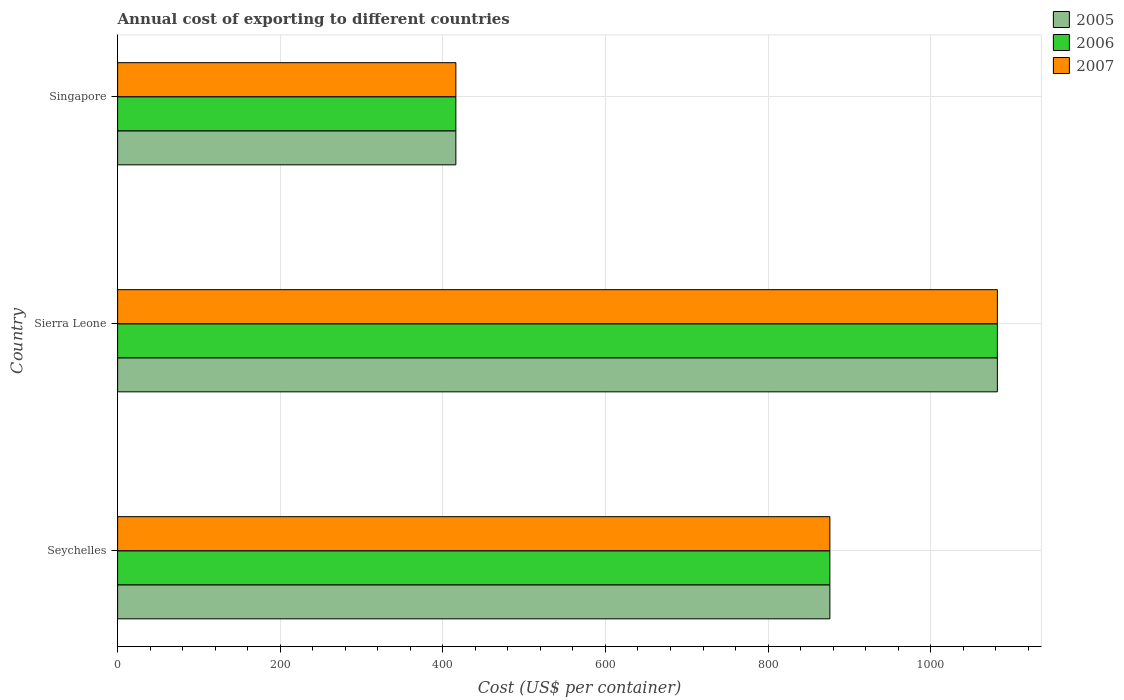Are the number of bars per tick equal to the number of legend labels?
Your answer should be compact. Yes. Are the number of bars on each tick of the Y-axis equal?
Offer a terse response. Yes. What is the label of the 1st group of bars from the top?
Provide a short and direct response. Singapore. In how many cases, is the number of bars for a given country not equal to the number of legend labels?
Provide a short and direct response. 0. What is the total annual cost of exporting in 2007 in Singapore?
Offer a terse response. 416. Across all countries, what is the maximum total annual cost of exporting in 2007?
Give a very brief answer. 1082. Across all countries, what is the minimum total annual cost of exporting in 2007?
Your response must be concise. 416. In which country was the total annual cost of exporting in 2007 maximum?
Offer a very short reply. Sierra Leone. In which country was the total annual cost of exporting in 2007 minimum?
Make the answer very short. Singapore. What is the total total annual cost of exporting in 2006 in the graph?
Offer a very short reply. 2374. What is the difference between the total annual cost of exporting in 2006 in Seychelles and that in Singapore?
Offer a terse response. 460. What is the difference between the total annual cost of exporting in 2005 in Sierra Leone and the total annual cost of exporting in 2006 in Seychelles?
Your answer should be very brief. 206. What is the average total annual cost of exporting in 2006 per country?
Your response must be concise. 791.33. What is the ratio of the total annual cost of exporting in 2007 in Seychelles to that in Sierra Leone?
Offer a terse response. 0.81. Is the total annual cost of exporting in 2005 in Sierra Leone less than that in Singapore?
Your response must be concise. No. What is the difference between the highest and the second highest total annual cost of exporting in 2005?
Offer a very short reply. 206. What is the difference between the highest and the lowest total annual cost of exporting in 2007?
Provide a succinct answer. 666. What does the 3rd bar from the top in Seychelles represents?
Offer a terse response. 2005. What does the 3rd bar from the bottom in Singapore represents?
Make the answer very short. 2007. Is it the case that in every country, the sum of the total annual cost of exporting in 2006 and total annual cost of exporting in 2007 is greater than the total annual cost of exporting in 2005?
Offer a very short reply. Yes. How many bars are there?
Ensure brevity in your answer.  9. Are all the bars in the graph horizontal?
Ensure brevity in your answer.  Yes. What is the difference between two consecutive major ticks on the X-axis?
Make the answer very short. 200. Does the graph contain any zero values?
Your answer should be compact. No. Does the graph contain grids?
Your answer should be compact. Yes. Where does the legend appear in the graph?
Ensure brevity in your answer.  Top right. What is the title of the graph?
Your response must be concise. Annual cost of exporting to different countries. Does "1996" appear as one of the legend labels in the graph?
Make the answer very short. No. What is the label or title of the X-axis?
Make the answer very short. Cost (US$ per container). What is the Cost (US$ per container) of 2005 in Seychelles?
Provide a short and direct response. 876. What is the Cost (US$ per container) in 2006 in Seychelles?
Your answer should be very brief. 876. What is the Cost (US$ per container) in 2007 in Seychelles?
Make the answer very short. 876. What is the Cost (US$ per container) in 2005 in Sierra Leone?
Provide a succinct answer. 1082. What is the Cost (US$ per container) of 2006 in Sierra Leone?
Provide a short and direct response. 1082. What is the Cost (US$ per container) in 2007 in Sierra Leone?
Ensure brevity in your answer.  1082. What is the Cost (US$ per container) of 2005 in Singapore?
Provide a succinct answer. 416. What is the Cost (US$ per container) in 2006 in Singapore?
Offer a very short reply. 416. What is the Cost (US$ per container) of 2007 in Singapore?
Keep it short and to the point. 416. Across all countries, what is the maximum Cost (US$ per container) of 2005?
Give a very brief answer. 1082. Across all countries, what is the maximum Cost (US$ per container) of 2006?
Provide a short and direct response. 1082. Across all countries, what is the maximum Cost (US$ per container) of 2007?
Your answer should be very brief. 1082. Across all countries, what is the minimum Cost (US$ per container) of 2005?
Your answer should be very brief. 416. Across all countries, what is the minimum Cost (US$ per container) in 2006?
Keep it short and to the point. 416. Across all countries, what is the minimum Cost (US$ per container) in 2007?
Your answer should be compact. 416. What is the total Cost (US$ per container) of 2005 in the graph?
Give a very brief answer. 2374. What is the total Cost (US$ per container) in 2006 in the graph?
Your answer should be very brief. 2374. What is the total Cost (US$ per container) in 2007 in the graph?
Give a very brief answer. 2374. What is the difference between the Cost (US$ per container) in 2005 in Seychelles and that in Sierra Leone?
Ensure brevity in your answer.  -206. What is the difference between the Cost (US$ per container) in 2006 in Seychelles and that in Sierra Leone?
Offer a terse response. -206. What is the difference between the Cost (US$ per container) of 2007 in Seychelles and that in Sierra Leone?
Keep it short and to the point. -206. What is the difference between the Cost (US$ per container) in 2005 in Seychelles and that in Singapore?
Provide a succinct answer. 460. What is the difference between the Cost (US$ per container) of 2006 in Seychelles and that in Singapore?
Your response must be concise. 460. What is the difference between the Cost (US$ per container) in 2007 in Seychelles and that in Singapore?
Provide a short and direct response. 460. What is the difference between the Cost (US$ per container) of 2005 in Sierra Leone and that in Singapore?
Provide a short and direct response. 666. What is the difference between the Cost (US$ per container) of 2006 in Sierra Leone and that in Singapore?
Ensure brevity in your answer.  666. What is the difference between the Cost (US$ per container) of 2007 in Sierra Leone and that in Singapore?
Ensure brevity in your answer.  666. What is the difference between the Cost (US$ per container) in 2005 in Seychelles and the Cost (US$ per container) in 2006 in Sierra Leone?
Keep it short and to the point. -206. What is the difference between the Cost (US$ per container) of 2005 in Seychelles and the Cost (US$ per container) of 2007 in Sierra Leone?
Give a very brief answer. -206. What is the difference between the Cost (US$ per container) in 2006 in Seychelles and the Cost (US$ per container) in 2007 in Sierra Leone?
Ensure brevity in your answer.  -206. What is the difference between the Cost (US$ per container) in 2005 in Seychelles and the Cost (US$ per container) in 2006 in Singapore?
Make the answer very short. 460. What is the difference between the Cost (US$ per container) of 2005 in Seychelles and the Cost (US$ per container) of 2007 in Singapore?
Give a very brief answer. 460. What is the difference between the Cost (US$ per container) in 2006 in Seychelles and the Cost (US$ per container) in 2007 in Singapore?
Keep it short and to the point. 460. What is the difference between the Cost (US$ per container) in 2005 in Sierra Leone and the Cost (US$ per container) in 2006 in Singapore?
Your answer should be very brief. 666. What is the difference between the Cost (US$ per container) in 2005 in Sierra Leone and the Cost (US$ per container) in 2007 in Singapore?
Keep it short and to the point. 666. What is the difference between the Cost (US$ per container) of 2006 in Sierra Leone and the Cost (US$ per container) of 2007 in Singapore?
Your response must be concise. 666. What is the average Cost (US$ per container) of 2005 per country?
Provide a short and direct response. 791.33. What is the average Cost (US$ per container) in 2006 per country?
Make the answer very short. 791.33. What is the average Cost (US$ per container) of 2007 per country?
Provide a succinct answer. 791.33. What is the difference between the Cost (US$ per container) of 2005 and Cost (US$ per container) of 2007 in Seychelles?
Provide a short and direct response. 0. What is the difference between the Cost (US$ per container) in 2006 and Cost (US$ per container) in 2007 in Seychelles?
Ensure brevity in your answer.  0. What is the difference between the Cost (US$ per container) of 2005 and Cost (US$ per container) of 2006 in Sierra Leone?
Your answer should be very brief. 0. What is the difference between the Cost (US$ per container) in 2006 and Cost (US$ per container) in 2007 in Sierra Leone?
Offer a very short reply. 0. What is the difference between the Cost (US$ per container) of 2005 and Cost (US$ per container) of 2007 in Singapore?
Your answer should be compact. 0. What is the difference between the Cost (US$ per container) in 2006 and Cost (US$ per container) in 2007 in Singapore?
Provide a succinct answer. 0. What is the ratio of the Cost (US$ per container) in 2005 in Seychelles to that in Sierra Leone?
Offer a very short reply. 0.81. What is the ratio of the Cost (US$ per container) in 2006 in Seychelles to that in Sierra Leone?
Offer a very short reply. 0.81. What is the ratio of the Cost (US$ per container) in 2007 in Seychelles to that in Sierra Leone?
Give a very brief answer. 0.81. What is the ratio of the Cost (US$ per container) in 2005 in Seychelles to that in Singapore?
Give a very brief answer. 2.11. What is the ratio of the Cost (US$ per container) of 2006 in Seychelles to that in Singapore?
Offer a terse response. 2.11. What is the ratio of the Cost (US$ per container) of 2007 in Seychelles to that in Singapore?
Your answer should be compact. 2.11. What is the ratio of the Cost (US$ per container) in 2005 in Sierra Leone to that in Singapore?
Your answer should be compact. 2.6. What is the ratio of the Cost (US$ per container) of 2006 in Sierra Leone to that in Singapore?
Ensure brevity in your answer.  2.6. What is the ratio of the Cost (US$ per container) of 2007 in Sierra Leone to that in Singapore?
Give a very brief answer. 2.6. What is the difference between the highest and the second highest Cost (US$ per container) in 2005?
Provide a short and direct response. 206. What is the difference between the highest and the second highest Cost (US$ per container) in 2006?
Offer a very short reply. 206. What is the difference between the highest and the second highest Cost (US$ per container) of 2007?
Offer a very short reply. 206. What is the difference between the highest and the lowest Cost (US$ per container) in 2005?
Give a very brief answer. 666. What is the difference between the highest and the lowest Cost (US$ per container) of 2006?
Offer a very short reply. 666. What is the difference between the highest and the lowest Cost (US$ per container) of 2007?
Offer a very short reply. 666. 